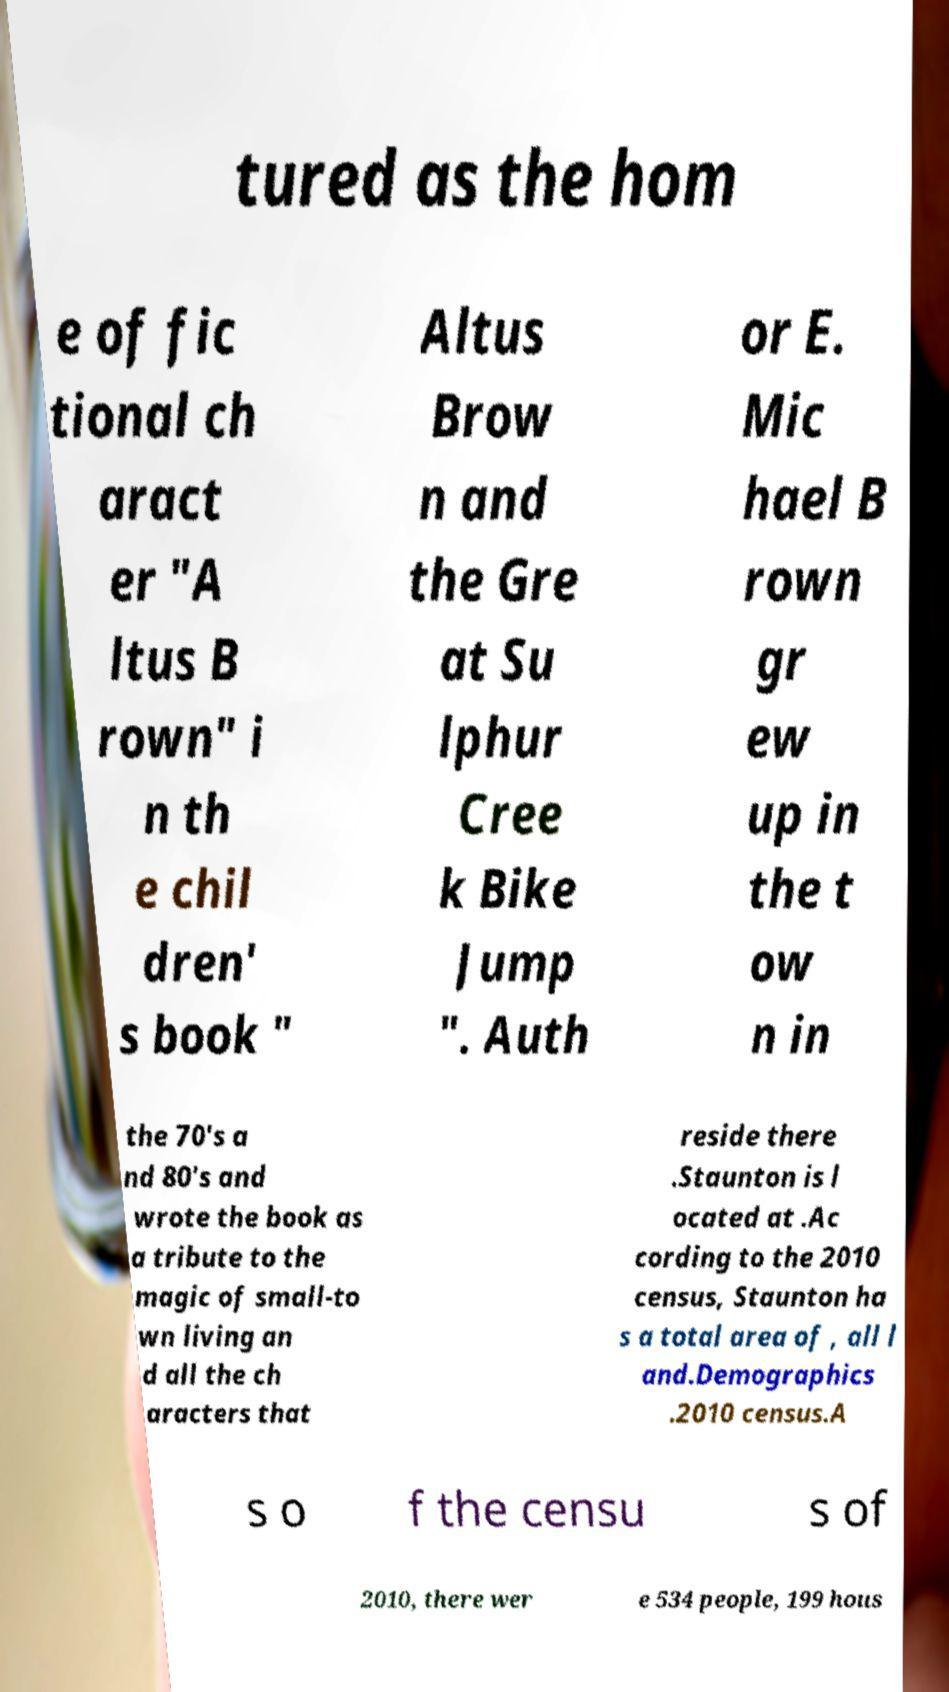For documentation purposes, I need the text within this image transcribed. Could you provide that? tured as the hom e of fic tional ch aract er "A ltus B rown" i n th e chil dren' s book " Altus Brow n and the Gre at Su lphur Cree k Bike Jump ". Auth or E. Mic hael B rown gr ew up in the t ow n in the 70's a nd 80's and wrote the book as a tribute to the magic of small-to wn living an d all the ch aracters that reside there .Staunton is l ocated at .Ac cording to the 2010 census, Staunton ha s a total area of , all l and.Demographics .2010 census.A s o f the censu s of 2010, there wer e 534 people, 199 hous 